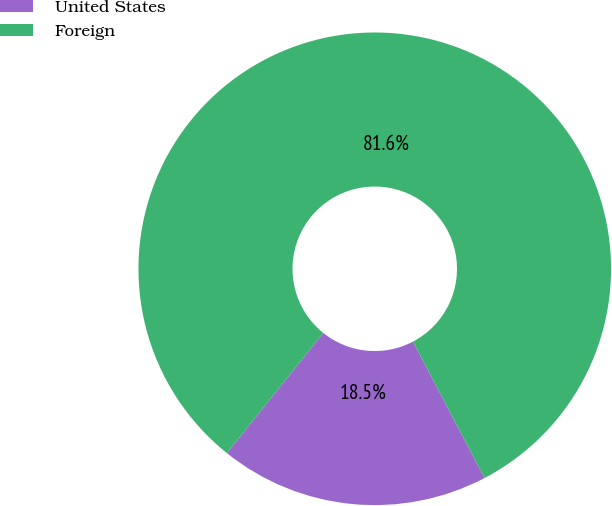<chart> <loc_0><loc_0><loc_500><loc_500><pie_chart><fcel>United States<fcel>Foreign<nl><fcel>18.45%<fcel>81.55%<nl></chart> 